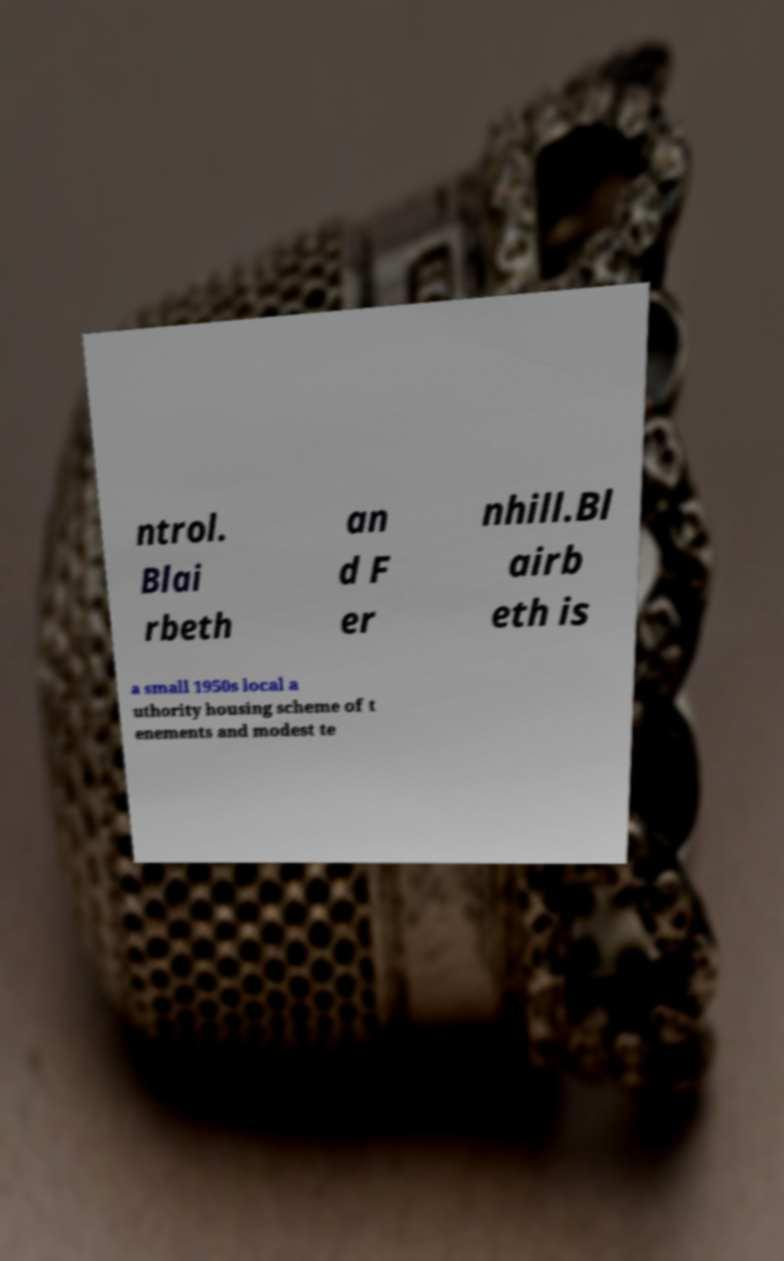What messages or text are displayed in this image? I need them in a readable, typed format. ntrol. Blai rbeth an d F er nhill.Bl airb eth is a small 1950s local a uthority housing scheme of t enements and modest te 